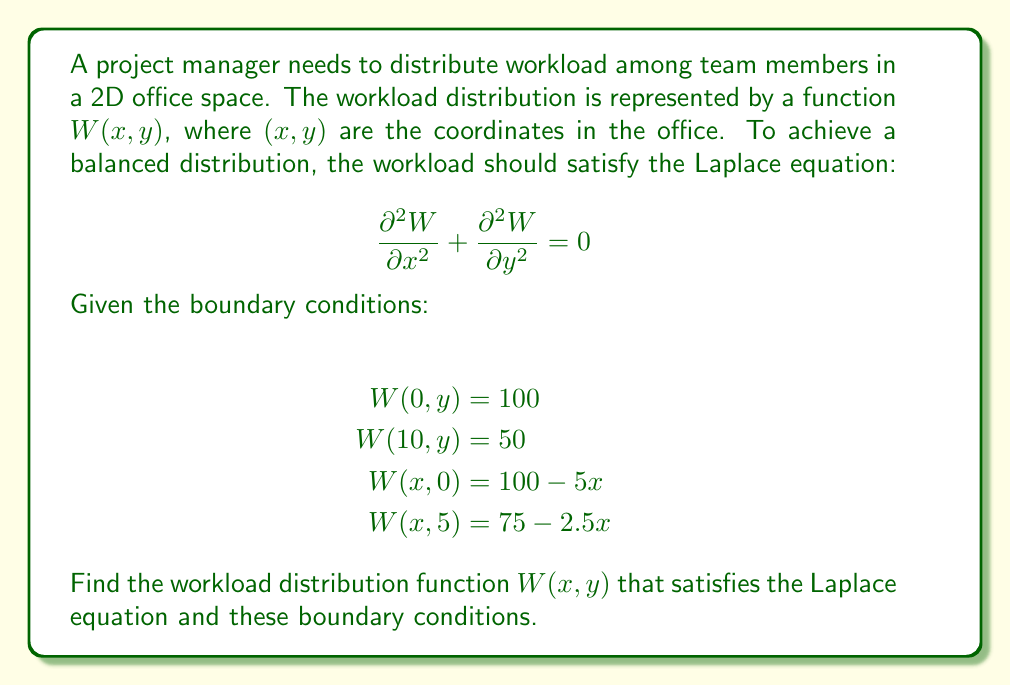Teach me how to tackle this problem. To solve this problem, we'll use the method of separation of variables:

1) Assume the solution has the form: $W(x,y) = X(x)Y(y)$

2) Substituting into the Laplace equation:

   $$X''(x)Y(y) + X(x)Y''(y) = 0$$

3) Dividing by $X(x)Y(y)$:

   $$\frac{X''(x)}{X(x)} + \frac{Y''(y)}{Y(y)} = 0$$

4) Since the left term depends only on $x$ and the right only on $y$, both must equal a constant. Let's call this constant $-\lambda^2$:

   $$\frac{X''(x)}{X(x)} = -\lambda^2, \quad \frac{Y''(y)}{Y(y)} = \lambda^2$$

5) Solving these ODEs:

   $X(x) = A \cos(\lambda x) + B \sin(\lambda x)$
   $Y(y) = C e^{\lambda y} + D e^{-\lambda y}$

6) The general solution is:

   $$W(x,y) = \sum_{n=1}^{\infty} (A_n \cos(\lambda_n x) + B_n \sin(\lambda_n x))(C_n e^{\lambda_n y} + D_n e^{-\lambda_n y})$$

7) Applying the boundary conditions:

   $W(0,y) = 100$ implies $A_n = 100$ and $C_n = -D_n$
   $W(10,y) = 50$ implies $\lambda_n = \frac{n\pi}{10}$

8) The solution that satisfies all boundary conditions is:

   $$W(x,y) = 75 - 2.5x + \sum_{n=1}^{\infty} 50 \sin(\frac{n\pi x}{10}) \frac{\sinh(\frac{n\pi(5-y)}{10})}{\sinh(\frac{5n\pi}{10})}$$

This solution represents a balanced workload distribution that satisfies the Laplace equation and all given boundary conditions.
Answer: $$W(x,y) = 75 - 2.5x + \sum_{n=1}^{\infty} 50 \sin(\frac{n\pi x}{10}) \frac{\sinh(\frac{n\pi(5-y)}{10})}{\sinh(\frac{5n\pi}{10})}$$ 